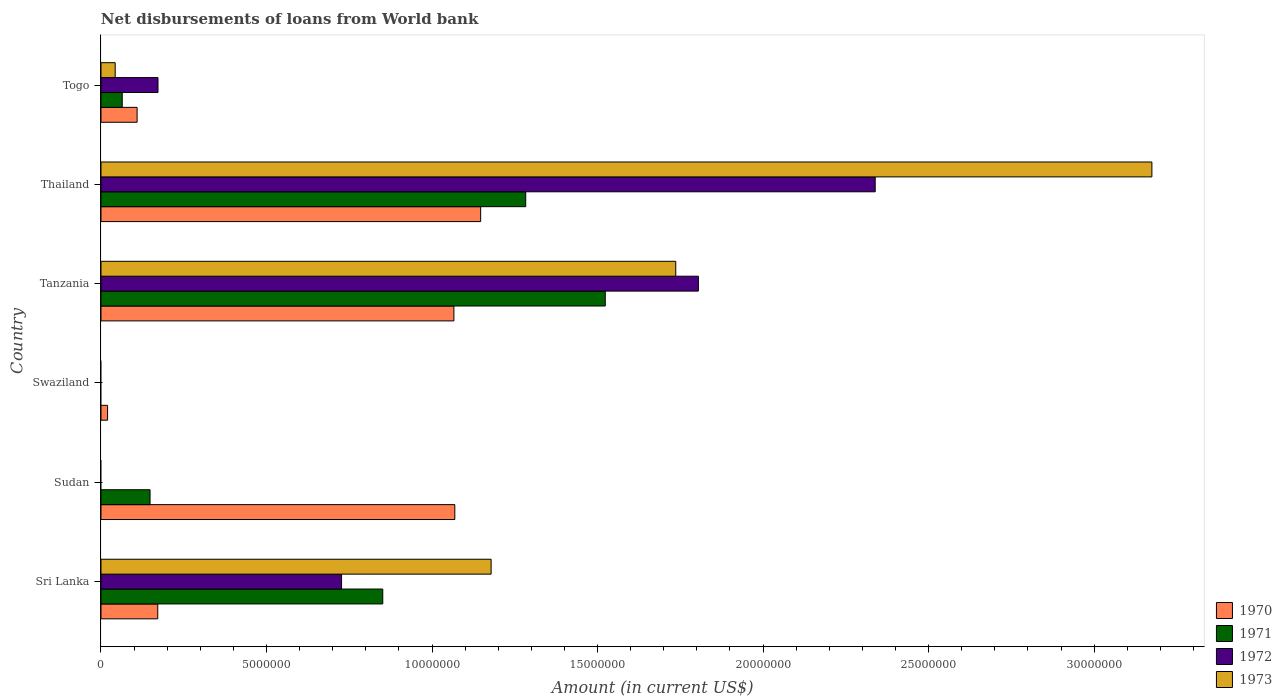How many different coloured bars are there?
Offer a very short reply. 4. How many bars are there on the 6th tick from the bottom?
Give a very brief answer. 4. What is the label of the 4th group of bars from the top?
Offer a terse response. Swaziland. In how many cases, is the number of bars for a given country not equal to the number of legend labels?
Give a very brief answer. 2. What is the amount of loan disbursed from World Bank in 1972 in Sri Lanka?
Provide a short and direct response. 7.27e+06. Across all countries, what is the maximum amount of loan disbursed from World Bank in 1971?
Give a very brief answer. 1.52e+07. Across all countries, what is the minimum amount of loan disbursed from World Bank in 1972?
Provide a short and direct response. 0. In which country was the amount of loan disbursed from World Bank in 1973 maximum?
Make the answer very short. Thailand. What is the total amount of loan disbursed from World Bank in 1973 in the graph?
Your answer should be very brief. 6.13e+07. What is the difference between the amount of loan disbursed from World Bank in 1973 in Tanzania and that in Thailand?
Offer a very short reply. -1.44e+07. What is the difference between the amount of loan disbursed from World Bank in 1972 in Tanzania and the amount of loan disbursed from World Bank in 1970 in Thailand?
Your answer should be very brief. 6.58e+06. What is the average amount of loan disbursed from World Bank in 1972 per country?
Offer a terse response. 8.40e+06. What is the difference between the amount of loan disbursed from World Bank in 1971 and amount of loan disbursed from World Bank in 1973 in Tanzania?
Provide a short and direct response. -2.13e+06. In how many countries, is the amount of loan disbursed from World Bank in 1970 greater than 12000000 US$?
Your response must be concise. 0. What is the ratio of the amount of loan disbursed from World Bank in 1970 in Thailand to that in Togo?
Your answer should be very brief. 10.51. Is the difference between the amount of loan disbursed from World Bank in 1971 in Sri Lanka and Togo greater than the difference between the amount of loan disbursed from World Bank in 1973 in Sri Lanka and Togo?
Keep it short and to the point. No. What is the difference between the highest and the second highest amount of loan disbursed from World Bank in 1971?
Give a very brief answer. 2.40e+06. What is the difference between the highest and the lowest amount of loan disbursed from World Bank in 1970?
Offer a terse response. 1.13e+07. Is it the case that in every country, the sum of the amount of loan disbursed from World Bank in 1973 and amount of loan disbursed from World Bank in 1970 is greater than the sum of amount of loan disbursed from World Bank in 1972 and amount of loan disbursed from World Bank in 1971?
Provide a succinct answer. No. How many countries are there in the graph?
Your response must be concise. 6. Where does the legend appear in the graph?
Provide a succinct answer. Bottom right. How are the legend labels stacked?
Provide a succinct answer. Vertical. What is the title of the graph?
Give a very brief answer. Net disbursements of loans from World bank. Does "1973" appear as one of the legend labels in the graph?
Provide a succinct answer. Yes. What is the label or title of the Y-axis?
Offer a terse response. Country. What is the Amount (in current US$) in 1970 in Sri Lanka?
Make the answer very short. 1.72e+06. What is the Amount (in current US$) in 1971 in Sri Lanka?
Your answer should be very brief. 8.51e+06. What is the Amount (in current US$) in 1972 in Sri Lanka?
Keep it short and to the point. 7.27e+06. What is the Amount (in current US$) in 1973 in Sri Lanka?
Offer a very short reply. 1.18e+07. What is the Amount (in current US$) of 1970 in Sudan?
Ensure brevity in your answer.  1.07e+07. What is the Amount (in current US$) in 1971 in Sudan?
Offer a terse response. 1.48e+06. What is the Amount (in current US$) of 1973 in Sudan?
Make the answer very short. 0. What is the Amount (in current US$) in 1970 in Swaziland?
Ensure brevity in your answer.  1.99e+05. What is the Amount (in current US$) in 1973 in Swaziland?
Keep it short and to the point. 0. What is the Amount (in current US$) of 1970 in Tanzania?
Ensure brevity in your answer.  1.07e+07. What is the Amount (in current US$) in 1971 in Tanzania?
Offer a very short reply. 1.52e+07. What is the Amount (in current US$) of 1972 in Tanzania?
Offer a very short reply. 1.80e+07. What is the Amount (in current US$) of 1973 in Tanzania?
Provide a succinct answer. 1.74e+07. What is the Amount (in current US$) in 1970 in Thailand?
Ensure brevity in your answer.  1.15e+07. What is the Amount (in current US$) of 1971 in Thailand?
Ensure brevity in your answer.  1.28e+07. What is the Amount (in current US$) in 1972 in Thailand?
Offer a terse response. 2.34e+07. What is the Amount (in current US$) of 1973 in Thailand?
Give a very brief answer. 3.17e+07. What is the Amount (in current US$) of 1970 in Togo?
Your answer should be very brief. 1.09e+06. What is the Amount (in current US$) of 1971 in Togo?
Make the answer very short. 6.42e+05. What is the Amount (in current US$) of 1972 in Togo?
Ensure brevity in your answer.  1.72e+06. What is the Amount (in current US$) of 1973 in Togo?
Make the answer very short. 4.29e+05. Across all countries, what is the maximum Amount (in current US$) in 1970?
Ensure brevity in your answer.  1.15e+07. Across all countries, what is the maximum Amount (in current US$) of 1971?
Ensure brevity in your answer.  1.52e+07. Across all countries, what is the maximum Amount (in current US$) in 1972?
Keep it short and to the point. 2.34e+07. Across all countries, what is the maximum Amount (in current US$) in 1973?
Ensure brevity in your answer.  3.17e+07. Across all countries, what is the minimum Amount (in current US$) in 1970?
Ensure brevity in your answer.  1.99e+05. Across all countries, what is the minimum Amount (in current US$) in 1972?
Make the answer very short. 0. Across all countries, what is the minimum Amount (in current US$) of 1973?
Your answer should be very brief. 0. What is the total Amount (in current US$) in 1970 in the graph?
Offer a very short reply. 3.58e+07. What is the total Amount (in current US$) in 1971 in the graph?
Ensure brevity in your answer.  3.87e+07. What is the total Amount (in current US$) of 1972 in the graph?
Give a very brief answer. 5.04e+07. What is the total Amount (in current US$) in 1973 in the graph?
Offer a terse response. 6.13e+07. What is the difference between the Amount (in current US$) in 1970 in Sri Lanka and that in Sudan?
Make the answer very short. -8.97e+06. What is the difference between the Amount (in current US$) of 1971 in Sri Lanka and that in Sudan?
Offer a very short reply. 7.03e+06. What is the difference between the Amount (in current US$) in 1970 in Sri Lanka and that in Swaziland?
Provide a short and direct response. 1.52e+06. What is the difference between the Amount (in current US$) of 1970 in Sri Lanka and that in Tanzania?
Your answer should be compact. -8.95e+06. What is the difference between the Amount (in current US$) of 1971 in Sri Lanka and that in Tanzania?
Make the answer very short. -6.72e+06. What is the difference between the Amount (in current US$) in 1972 in Sri Lanka and that in Tanzania?
Offer a terse response. -1.08e+07. What is the difference between the Amount (in current US$) of 1973 in Sri Lanka and that in Tanzania?
Offer a terse response. -5.58e+06. What is the difference between the Amount (in current US$) of 1970 in Sri Lanka and that in Thailand?
Give a very brief answer. -9.75e+06. What is the difference between the Amount (in current US$) of 1971 in Sri Lanka and that in Thailand?
Your answer should be very brief. -4.32e+06. What is the difference between the Amount (in current US$) of 1972 in Sri Lanka and that in Thailand?
Make the answer very short. -1.61e+07. What is the difference between the Amount (in current US$) in 1973 in Sri Lanka and that in Thailand?
Your response must be concise. -2.00e+07. What is the difference between the Amount (in current US$) of 1970 in Sri Lanka and that in Togo?
Your answer should be very brief. 6.24e+05. What is the difference between the Amount (in current US$) of 1971 in Sri Lanka and that in Togo?
Give a very brief answer. 7.87e+06. What is the difference between the Amount (in current US$) of 1972 in Sri Lanka and that in Togo?
Give a very brief answer. 5.54e+06. What is the difference between the Amount (in current US$) of 1973 in Sri Lanka and that in Togo?
Make the answer very short. 1.14e+07. What is the difference between the Amount (in current US$) in 1970 in Sudan and that in Swaziland?
Make the answer very short. 1.05e+07. What is the difference between the Amount (in current US$) in 1970 in Sudan and that in Tanzania?
Make the answer very short. 2.70e+04. What is the difference between the Amount (in current US$) in 1971 in Sudan and that in Tanzania?
Keep it short and to the point. -1.38e+07. What is the difference between the Amount (in current US$) of 1970 in Sudan and that in Thailand?
Offer a terse response. -7.81e+05. What is the difference between the Amount (in current US$) in 1971 in Sudan and that in Thailand?
Make the answer very short. -1.13e+07. What is the difference between the Amount (in current US$) in 1970 in Sudan and that in Togo?
Offer a very short reply. 9.60e+06. What is the difference between the Amount (in current US$) in 1971 in Sudan and that in Togo?
Your answer should be very brief. 8.40e+05. What is the difference between the Amount (in current US$) in 1970 in Swaziland and that in Tanzania?
Provide a succinct answer. -1.05e+07. What is the difference between the Amount (in current US$) in 1970 in Swaziland and that in Thailand?
Your answer should be compact. -1.13e+07. What is the difference between the Amount (in current US$) in 1970 in Swaziland and that in Togo?
Make the answer very short. -8.92e+05. What is the difference between the Amount (in current US$) of 1970 in Tanzania and that in Thailand?
Keep it short and to the point. -8.08e+05. What is the difference between the Amount (in current US$) of 1971 in Tanzania and that in Thailand?
Offer a very short reply. 2.40e+06. What is the difference between the Amount (in current US$) of 1972 in Tanzania and that in Thailand?
Offer a very short reply. -5.34e+06. What is the difference between the Amount (in current US$) of 1973 in Tanzania and that in Thailand?
Keep it short and to the point. -1.44e+07. What is the difference between the Amount (in current US$) in 1970 in Tanzania and that in Togo?
Your answer should be compact. 9.57e+06. What is the difference between the Amount (in current US$) in 1971 in Tanzania and that in Togo?
Ensure brevity in your answer.  1.46e+07. What is the difference between the Amount (in current US$) of 1972 in Tanzania and that in Togo?
Provide a short and direct response. 1.63e+07. What is the difference between the Amount (in current US$) of 1973 in Tanzania and that in Togo?
Your answer should be compact. 1.69e+07. What is the difference between the Amount (in current US$) of 1970 in Thailand and that in Togo?
Provide a short and direct response. 1.04e+07. What is the difference between the Amount (in current US$) in 1971 in Thailand and that in Togo?
Give a very brief answer. 1.22e+07. What is the difference between the Amount (in current US$) of 1972 in Thailand and that in Togo?
Your answer should be compact. 2.17e+07. What is the difference between the Amount (in current US$) in 1973 in Thailand and that in Togo?
Provide a short and direct response. 3.13e+07. What is the difference between the Amount (in current US$) in 1970 in Sri Lanka and the Amount (in current US$) in 1971 in Sudan?
Your answer should be compact. 2.33e+05. What is the difference between the Amount (in current US$) of 1970 in Sri Lanka and the Amount (in current US$) of 1971 in Tanzania?
Offer a terse response. -1.35e+07. What is the difference between the Amount (in current US$) in 1970 in Sri Lanka and the Amount (in current US$) in 1972 in Tanzania?
Your response must be concise. -1.63e+07. What is the difference between the Amount (in current US$) of 1970 in Sri Lanka and the Amount (in current US$) of 1973 in Tanzania?
Your answer should be very brief. -1.56e+07. What is the difference between the Amount (in current US$) of 1971 in Sri Lanka and the Amount (in current US$) of 1972 in Tanzania?
Your answer should be compact. -9.53e+06. What is the difference between the Amount (in current US$) in 1971 in Sri Lanka and the Amount (in current US$) in 1973 in Tanzania?
Offer a terse response. -8.85e+06. What is the difference between the Amount (in current US$) of 1972 in Sri Lanka and the Amount (in current US$) of 1973 in Tanzania?
Offer a terse response. -1.01e+07. What is the difference between the Amount (in current US$) of 1970 in Sri Lanka and the Amount (in current US$) of 1971 in Thailand?
Your answer should be compact. -1.11e+07. What is the difference between the Amount (in current US$) in 1970 in Sri Lanka and the Amount (in current US$) in 1972 in Thailand?
Offer a terse response. -2.17e+07. What is the difference between the Amount (in current US$) in 1970 in Sri Lanka and the Amount (in current US$) in 1973 in Thailand?
Ensure brevity in your answer.  -3.00e+07. What is the difference between the Amount (in current US$) of 1971 in Sri Lanka and the Amount (in current US$) of 1972 in Thailand?
Offer a terse response. -1.49e+07. What is the difference between the Amount (in current US$) of 1971 in Sri Lanka and the Amount (in current US$) of 1973 in Thailand?
Give a very brief answer. -2.32e+07. What is the difference between the Amount (in current US$) of 1972 in Sri Lanka and the Amount (in current US$) of 1973 in Thailand?
Your answer should be compact. -2.45e+07. What is the difference between the Amount (in current US$) of 1970 in Sri Lanka and the Amount (in current US$) of 1971 in Togo?
Your answer should be compact. 1.07e+06. What is the difference between the Amount (in current US$) of 1970 in Sri Lanka and the Amount (in current US$) of 1972 in Togo?
Offer a very short reply. -7000. What is the difference between the Amount (in current US$) of 1970 in Sri Lanka and the Amount (in current US$) of 1973 in Togo?
Provide a succinct answer. 1.29e+06. What is the difference between the Amount (in current US$) in 1971 in Sri Lanka and the Amount (in current US$) in 1972 in Togo?
Give a very brief answer. 6.79e+06. What is the difference between the Amount (in current US$) in 1971 in Sri Lanka and the Amount (in current US$) in 1973 in Togo?
Make the answer very short. 8.08e+06. What is the difference between the Amount (in current US$) in 1972 in Sri Lanka and the Amount (in current US$) in 1973 in Togo?
Your answer should be very brief. 6.84e+06. What is the difference between the Amount (in current US$) in 1970 in Sudan and the Amount (in current US$) in 1971 in Tanzania?
Give a very brief answer. -4.54e+06. What is the difference between the Amount (in current US$) in 1970 in Sudan and the Amount (in current US$) in 1972 in Tanzania?
Offer a terse response. -7.36e+06. What is the difference between the Amount (in current US$) in 1970 in Sudan and the Amount (in current US$) in 1973 in Tanzania?
Make the answer very short. -6.67e+06. What is the difference between the Amount (in current US$) in 1971 in Sudan and the Amount (in current US$) in 1972 in Tanzania?
Your answer should be very brief. -1.66e+07. What is the difference between the Amount (in current US$) in 1971 in Sudan and the Amount (in current US$) in 1973 in Tanzania?
Your answer should be very brief. -1.59e+07. What is the difference between the Amount (in current US$) of 1970 in Sudan and the Amount (in current US$) of 1971 in Thailand?
Offer a very short reply. -2.14e+06. What is the difference between the Amount (in current US$) in 1970 in Sudan and the Amount (in current US$) in 1972 in Thailand?
Ensure brevity in your answer.  -1.27e+07. What is the difference between the Amount (in current US$) in 1970 in Sudan and the Amount (in current US$) in 1973 in Thailand?
Provide a succinct answer. -2.11e+07. What is the difference between the Amount (in current US$) of 1971 in Sudan and the Amount (in current US$) of 1972 in Thailand?
Provide a succinct answer. -2.19e+07. What is the difference between the Amount (in current US$) in 1971 in Sudan and the Amount (in current US$) in 1973 in Thailand?
Ensure brevity in your answer.  -3.03e+07. What is the difference between the Amount (in current US$) of 1970 in Sudan and the Amount (in current US$) of 1971 in Togo?
Your answer should be very brief. 1.00e+07. What is the difference between the Amount (in current US$) of 1970 in Sudan and the Amount (in current US$) of 1972 in Togo?
Keep it short and to the point. 8.97e+06. What is the difference between the Amount (in current US$) in 1970 in Sudan and the Amount (in current US$) in 1973 in Togo?
Provide a short and direct response. 1.03e+07. What is the difference between the Amount (in current US$) in 1971 in Sudan and the Amount (in current US$) in 1972 in Togo?
Make the answer very short. -2.40e+05. What is the difference between the Amount (in current US$) in 1971 in Sudan and the Amount (in current US$) in 1973 in Togo?
Your response must be concise. 1.05e+06. What is the difference between the Amount (in current US$) of 1970 in Swaziland and the Amount (in current US$) of 1971 in Tanzania?
Your answer should be compact. -1.50e+07. What is the difference between the Amount (in current US$) of 1970 in Swaziland and the Amount (in current US$) of 1972 in Tanzania?
Provide a succinct answer. -1.78e+07. What is the difference between the Amount (in current US$) in 1970 in Swaziland and the Amount (in current US$) in 1973 in Tanzania?
Make the answer very short. -1.72e+07. What is the difference between the Amount (in current US$) in 1970 in Swaziland and the Amount (in current US$) in 1971 in Thailand?
Provide a short and direct response. -1.26e+07. What is the difference between the Amount (in current US$) in 1970 in Swaziland and the Amount (in current US$) in 1972 in Thailand?
Your answer should be compact. -2.32e+07. What is the difference between the Amount (in current US$) of 1970 in Swaziland and the Amount (in current US$) of 1973 in Thailand?
Keep it short and to the point. -3.15e+07. What is the difference between the Amount (in current US$) of 1970 in Swaziland and the Amount (in current US$) of 1971 in Togo?
Your response must be concise. -4.43e+05. What is the difference between the Amount (in current US$) of 1970 in Swaziland and the Amount (in current US$) of 1972 in Togo?
Give a very brief answer. -1.52e+06. What is the difference between the Amount (in current US$) in 1970 in Tanzania and the Amount (in current US$) in 1971 in Thailand?
Make the answer very short. -2.17e+06. What is the difference between the Amount (in current US$) in 1970 in Tanzania and the Amount (in current US$) in 1972 in Thailand?
Offer a very short reply. -1.27e+07. What is the difference between the Amount (in current US$) in 1970 in Tanzania and the Amount (in current US$) in 1973 in Thailand?
Keep it short and to the point. -2.11e+07. What is the difference between the Amount (in current US$) in 1971 in Tanzania and the Amount (in current US$) in 1972 in Thailand?
Keep it short and to the point. -8.15e+06. What is the difference between the Amount (in current US$) in 1971 in Tanzania and the Amount (in current US$) in 1973 in Thailand?
Offer a very short reply. -1.65e+07. What is the difference between the Amount (in current US$) in 1972 in Tanzania and the Amount (in current US$) in 1973 in Thailand?
Make the answer very short. -1.37e+07. What is the difference between the Amount (in current US$) in 1970 in Tanzania and the Amount (in current US$) in 1971 in Togo?
Provide a succinct answer. 1.00e+07. What is the difference between the Amount (in current US$) in 1970 in Tanzania and the Amount (in current US$) in 1972 in Togo?
Make the answer very short. 8.94e+06. What is the difference between the Amount (in current US$) in 1970 in Tanzania and the Amount (in current US$) in 1973 in Togo?
Offer a terse response. 1.02e+07. What is the difference between the Amount (in current US$) in 1971 in Tanzania and the Amount (in current US$) in 1972 in Togo?
Ensure brevity in your answer.  1.35e+07. What is the difference between the Amount (in current US$) of 1971 in Tanzania and the Amount (in current US$) of 1973 in Togo?
Offer a very short reply. 1.48e+07. What is the difference between the Amount (in current US$) in 1972 in Tanzania and the Amount (in current US$) in 1973 in Togo?
Keep it short and to the point. 1.76e+07. What is the difference between the Amount (in current US$) of 1970 in Thailand and the Amount (in current US$) of 1971 in Togo?
Provide a short and direct response. 1.08e+07. What is the difference between the Amount (in current US$) in 1970 in Thailand and the Amount (in current US$) in 1972 in Togo?
Your response must be concise. 9.75e+06. What is the difference between the Amount (in current US$) in 1970 in Thailand and the Amount (in current US$) in 1973 in Togo?
Your response must be concise. 1.10e+07. What is the difference between the Amount (in current US$) in 1971 in Thailand and the Amount (in current US$) in 1972 in Togo?
Keep it short and to the point. 1.11e+07. What is the difference between the Amount (in current US$) in 1971 in Thailand and the Amount (in current US$) in 1973 in Togo?
Give a very brief answer. 1.24e+07. What is the difference between the Amount (in current US$) of 1972 in Thailand and the Amount (in current US$) of 1973 in Togo?
Ensure brevity in your answer.  2.30e+07. What is the average Amount (in current US$) of 1970 per country?
Offer a terse response. 5.97e+06. What is the average Amount (in current US$) in 1971 per country?
Your response must be concise. 6.45e+06. What is the average Amount (in current US$) of 1972 per country?
Your response must be concise. 8.40e+06. What is the average Amount (in current US$) in 1973 per country?
Your answer should be very brief. 1.02e+07. What is the difference between the Amount (in current US$) of 1970 and Amount (in current US$) of 1971 in Sri Lanka?
Give a very brief answer. -6.80e+06. What is the difference between the Amount (in current US$) in 1970 and Amount (in current US$) in 1972 in Sri Lanka?
Ensure brevity in your answer.  -5.55e+06. What is the difference between the Amount (in current US$) of 1970 and Amount (in current US$) of 1973 in Sri Lanka?
Keep it short and to the point. -1.01e+07. What is the difference between the Amount (in current US$) of 1971 and Amount (in current US$) of 1972 in Sri Lanka?
Your answer should be very brief. 1.24e+06. What is the difference between the Amount (in current US$) of 1971 and Amount (in current US$) of 1973 in Sri Lanka?
Offer a very short reply. -3.27e+06. What is the difference between the Amount (in current US$) of 1972 and Amount (in current US$) of 1973 in Sri Lanka?
Provide a short and direct response. -4.52e+06. What is the difference between the Amount (in current US$) in 1970 and Amount (in current US$) in 1971 in Sudan?
Your response must be concise. 9.21e+06. What is the difference between the Amount (in current US$) in 1970 and Amount (in current US$) in 1971 in Tanzania?
Give a very brief answer. -4.57e+06. What is the difference between the Amount (in current US$) of 1970 and Amount (in current US$) of 1972 in Tanzania?
Keep it short and to the point. -7.38e+06. What is the difference between the Amount (in current US$) of 1970 and Amount (in current US$) of 1973 in Tanzania?
Give a very brief answer. -6.70e+06. What is the difference between the Amount (in current US$) in 1971 and Amount (in current US$) in 1972 in Tanzania?
Your response must be concise. -2.81e+06. What is the difference between the Amount (in current US$) of 1971 and Amount (in current US$) of 1973 in Tanzania?
Your answer should be very brief. -2.13e+06. What is the difference between the Amount (in current US$) of 1972 and Amount (in current US$) of 1973 in Tanzania?
Ensure brevity in your answer.  6.84e+05. What is the difference between the Amount (in current US$) of 1970 and Amount (in current US$) of 1971 in Thailand?
Offer a terse response. -1.36e+06. What is the difference between the Amount (in current US$) in 1970 and Amount (in current US$) in 1972 in Thailand?
Your response must be concise. -1.19e+07. What is the difference between the Amount (in current US$) in 1970 and Amount (in current US$) in 1973 in Thailand?
Offer a terse response. -2.03e+07. What is the difference between the Amount (in current US$) in 1971 and Amount (in current US$) in 1972 in Thailand?
Give a very brief answer. -1.06e+07. What is the difference between the Amount (in current US$) in 1971 and Amount (in current US$) in 1973 in Thailand?
Keep it short and to the point. -1.89e+07. What is the difference between the Amount (in current US$) of 1972 and Amount (in current US$) of 1973 in Thailand?
Your answer should be very brief. -8.36e+06. What is the difference between the Amount (in current US$) in 1970 and Amount (in current US$) in 1971 in Togo?
Your response must be concise. 4.49e+05. What is the difference between the Amount (in current US$) in 1970 and Amount (in current US$) in 1972 in Togo?
Provide a succinct answer. -6.31e+05. What is the difference between the Amount (in current US$) in 1970 and Amount (in current US$) in 1973 in Togo?
Keep it short and to the point. 6.62e+05. What is the difference between the Amount (in current US$) of 1971 and Amount (in current US$) of 1972 in Togo?
Make the answer very short. -1.08e+06. What is the difference between the Amount (in current US$) in 1971 and Amount (in current US$) in 1973 in Togo?
Your answer should be very brief. 2.13e+05. What is the difference between the Amount (in current US$) of 1972 and Amount (in current US$) of 1973 in Togo?
Your response must be concise. 1.29e+06. What is the ratio of the Amount (in current US$) of 1970 in Sri Lanka to that in Sudan?
Your answer should be very brief. 0.16. What is the ratio of the Amount (in current US$) in 1971 in Sri Lanka to that in Sudan?
Your response must be concise. 5.74. What is the ratio of the Amount (in current US$) of 1970 in Sri Lanka to that in Swaziland?
Your response must be concise. 8.62. What is the ratio of the Amount (in current US$) in 1970 in Sri Lanka to that in Tanzania?
Ensure brevity in your answer.  0.16. What is the ratio of the Amount (in current US$) in 1971 in Sri Lanka to that in Tanzania?
Your answer should be compact. 0.56. What is the ratio of the Amount (in current US$) of 1972 in Sri Lanka to that in Tanzania?
Give a very brief answer. 0.4. What is the ratio of the Amount (in current US$) of 1973 in Sri Lanka to that in Tanzania?
Your answer should be very brief. 0.68. What is the ratio of the Amount (in current US$) in 1970 in Sri Lanka to that in Thailand?
Offer a very short reply. 0.15. What is the ratio of the Amount (in current US$) in 1971 in Sri Lanka to that in Thailand?
Your answer should be very brief. 0.66. What is the ratio of the Amount (in current US$) of 1972 in Sri Lanka to that in Thailand?
Ensure brevity in your answer.  0.31. What is the ratio of the Amount (in current US$) in 1973 in Sri Lanka to that in Thailand?
Your answer should be very brief. 0.37. What is the ratio of the Amount (in current US$) of 1970 in Sri Lanka to that in Togo?
Give a very brief answer. 1.57. What is the ratio of the Amount (in current US$) of 1971 in Sri Lanka to that in Togo?
Your answer should be compact. 13.26. What is the ratio of the Amount (in current US$) in 1972 in Sri Lanka to that in Togo?
Offer a terse response. 4.22. What is the ratio of the Amount (in current US$) in 1973 in Sri Lanka to that in Togo?
Your answer should be compact. 27.47. What is the ratio of the Amount (in current US$) in 1970 in Sudan to that in Swaziland?
Provide a short and direct response. 53.71. What is the ratio of the Amount (in current US$) of 1971 in Sudan to that in Tanzania?
Your answer should be very brief. 0.1. What is the ratio of the Amount (in current US$) in 1970 in Sudan to that in Thailand?
Offer a very short reply. 0.93. What is the ratio of the Amount (in current US$) in 1971 in Sudan to that in Thailand?
Give a very brief answer. 0.12. What is the ratio of the Amount (in current US$) of 1970 in Sudan to that in Togo?
Make the answer very short. 9.8. What is the ratio of the Amount (in current US$) of 1971 in Sudan to that in Togo?
Your answer should be compact. 2.31. What is the ratio of the Amount (in current US$) in 1970 in Swaziland to that in Tanzania?
Give a very brief answer. 0.02. What is the ratio of the Amount (in current US$) in 1970 in Swaziland to that in Thailand?
Ensure brevity in your answer.  0.02. What is the ratio of the Amount (in current US$) in 1970 in Swaziland to that in Togo?
Offer a terse response. 0.18. What is the ratio of the Amount (in current US$) in 1970 in Tanzania to that in Thailand?
Give a very brief answer. 0.93. What is the ratio of the Amount (in current US$) in 1971 in Tanzania to that in Thailand?
Keep it short and to the point. 1.19. What is the ratio of the Amount (in current US$) in 1972 in Tanzania to that in Thailand?
Keep it short and to the point. 0.77. What is the ratio of the Amount (in current US$) in 1973 in Tanzania to that in Thailand?
Make the answer very short. 0.55. What is the ratio of the Amount (in current US$) in 1970 in Tanzania to that in Togo?
Offer a very short reply. 9.77. What is the ratio of the Amount (in current US$) in 1971 in Tanzania to that in Togo?
Your answer should be very brief. 23.73. What is the ratio of the Amount (in current US$) in 1972 in Tanzania to that in Togo?
Your response must be concise. 10.48. What is the ratio of the Amount (in current US$) in 1973 in Tanzania to that in Togo?
Make the answer very short. 40.47. What is the ratio of the Amount (in current US$) in 1970 in Thailand to that in Togo?
Provide a succinct answer. 10.51. What is the ratio of the Amount (in current US$) in 1971 in Thailand to that in Togo?
Your answer should be compact. 19.98. What is the ratio of the Amount (in current US$) in 1972 in Thailand to that in Togo?
Offer a very short reply. 13.58. What is the ratio of the Amount (in current US$) in 1973 in Thailand to that in Togo?
Keep it short and to the point. 74. What is the difference between the highest and the second highest Amount (in current US$) in 1970?
Keep it short and to the point. 7.81e+05. What is the difference between the highest and the second highest Amount (in current US$) of 1971?
Provide a succinct answer. 2.40e+06. What is the difference between the highest and the second highest Amount (in current US$) in 1972?
Your response must be concise. 5.34e+06. What is the difference between the highest and the second highest Amount (in current US$) in 1973?
Ensure brevity in your answer.  1.44e+07. What is the difference between the highest and the lowest Amount (in current US$) of 1970?
Your response must be concise. 1.13e+07. What is the difference between the highest and the lowest Amount (in current US$) in 1971?
Your answer should be very brief. 1.52e+07. What is the difference between the highest and the lowest Amount (in current US$) in 1972?
Your response must be concise. 2.34e+07. What is the difference between the highest and the lowest Amount (in current US$) in 1973?
Keep it short and to the point. 3.17e+07. 